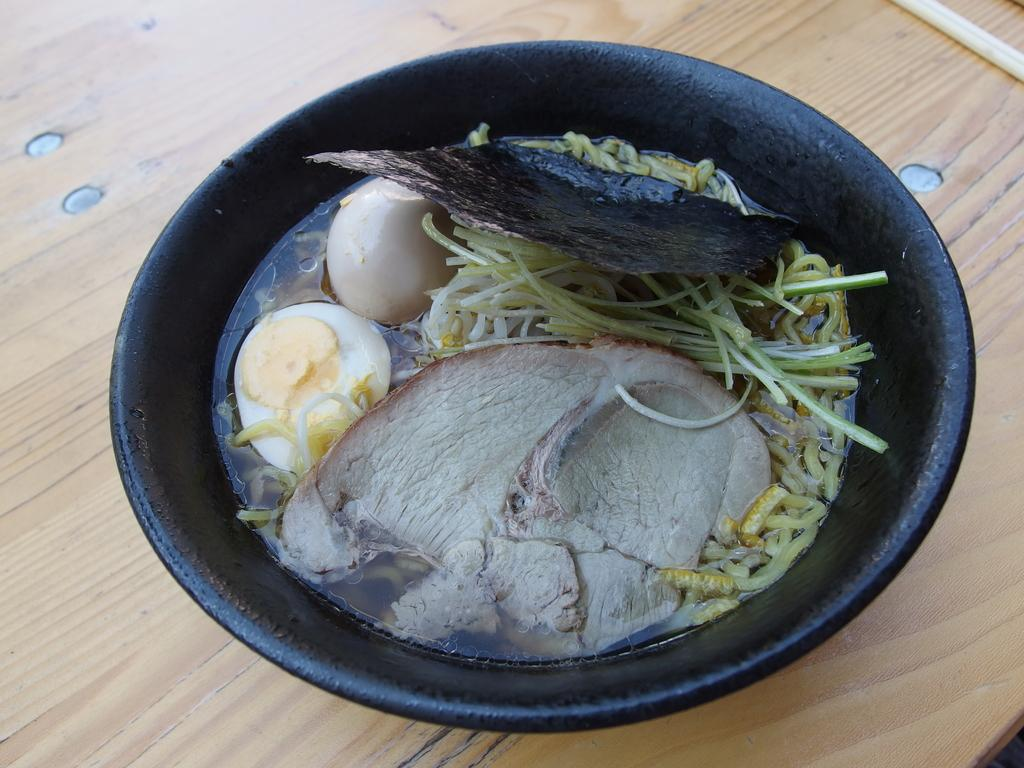What type of food can be seen in the image? The image contains food, but the specific type is not mentioned in the facts. How many colors can be observed in the food? The food has cream, white, yellow, and black colors. What color is the bowl containing the food? The bowl is black. Where is the bowl located in the image? The bowl is on a table. What value does the crate have in the image? There is no crate present in the image, so it is not possible to determine its value. 